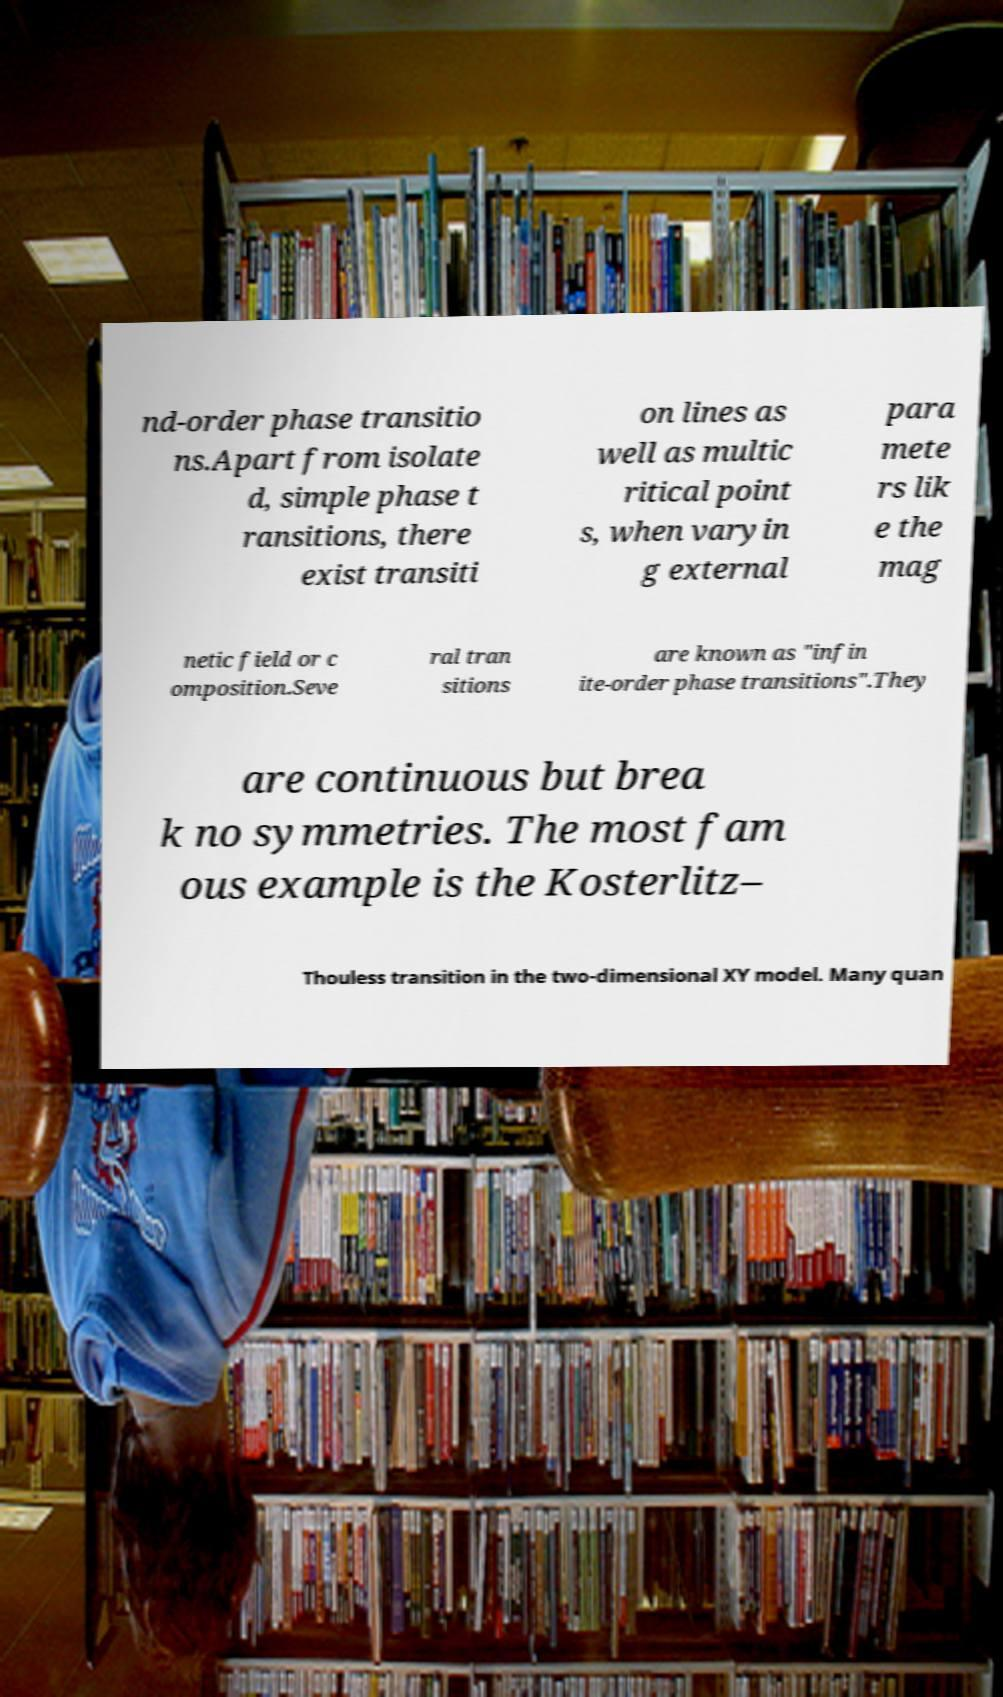Can you read and provide the text displayed in the image?This photo seems to have some interesting text. Can you extract and type it out for me? nd-order phase transitio ns.Apart from isolate d, simple phase t ransitions, there exist transiti on lines as well as multic ritical point s, when varyin g external para mete rs lik e the mag netic field or c omposition.Seve ral tran sitions are known as "infin ite-order phase transitions".They are continuous but brea k no symmetries. The most fam ous example is the Kosterlitz– Thouless transition in the two-dimensional XY model. Many quan 